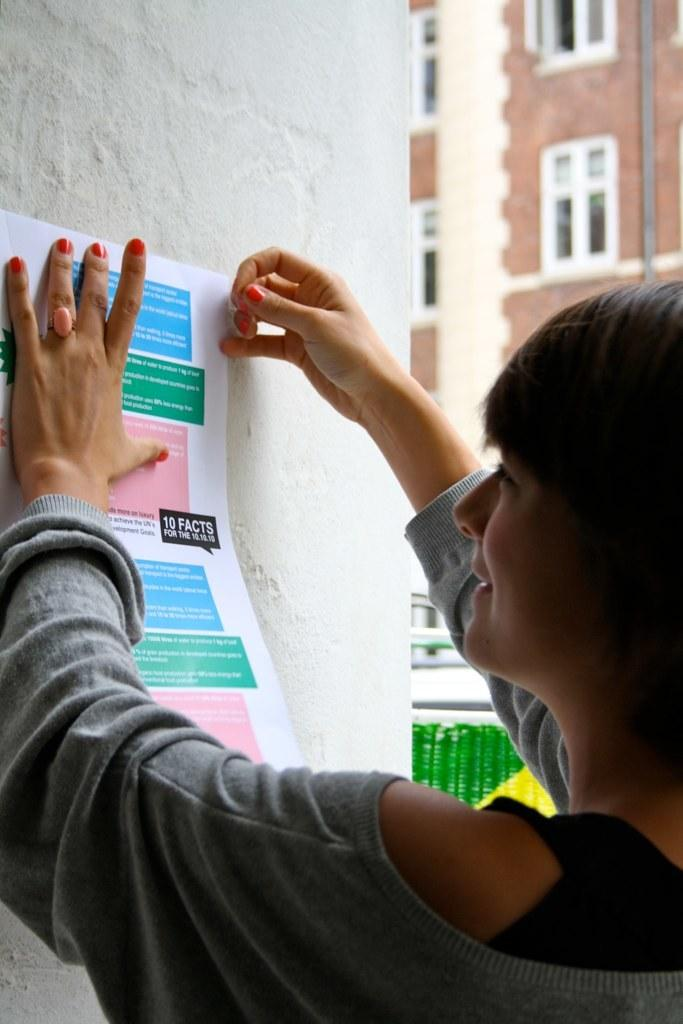What is the person in the image holding? The person is holding a paper in the image. Where is the paper located in the image? The paper is on the wall in the image. What can be seen in the background of the image? There is a building in the background of the image. What feature of the building is visible in the image? The building has windows. How many bells can be heard ringing in the image? There are no bells present in the image, so it is not possible to hear them ringing. 